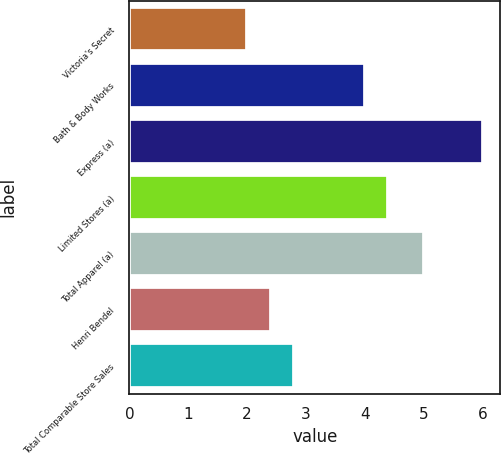<chart> <loc_0><loc_0><loc_500><loc_500><bar_chart><fcel>Victoria's Secret<fcel>Bath & Body Works<fcel>Express (a)<fcel>Limited Stores (a)<fcel>Total Apparel (a)<fcel>Henri Bendel<fcel>Total Comparable Store Sales<nl><fcel>2<fcel>4<fcel>6<fcel>4.4<fcel>5<fcel>2.4<fcel>2.8<nl></chart> 